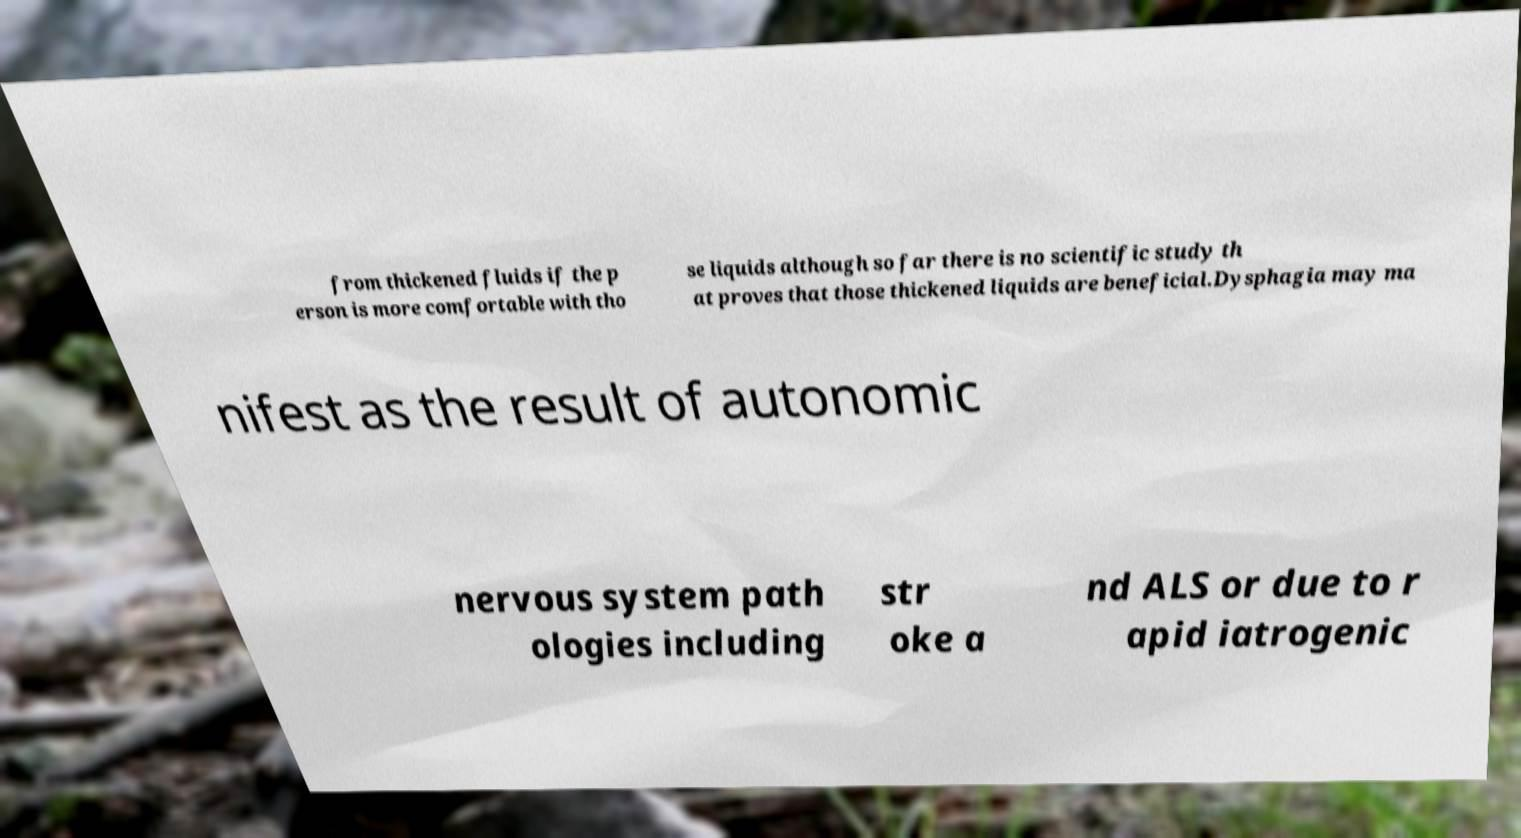For documentation purposes, I need the text within this image transcribed. Could you provide that? from thickened fluids if the p erson is more comfortable with tho se liquids although so far there is no scientific study th at proves that those thickened liquids are beneficial.Dysphagia may ma nifest as the result of autonomic nervous system path ologies including str oke a nd ALS or due to r apid iatrogenic 